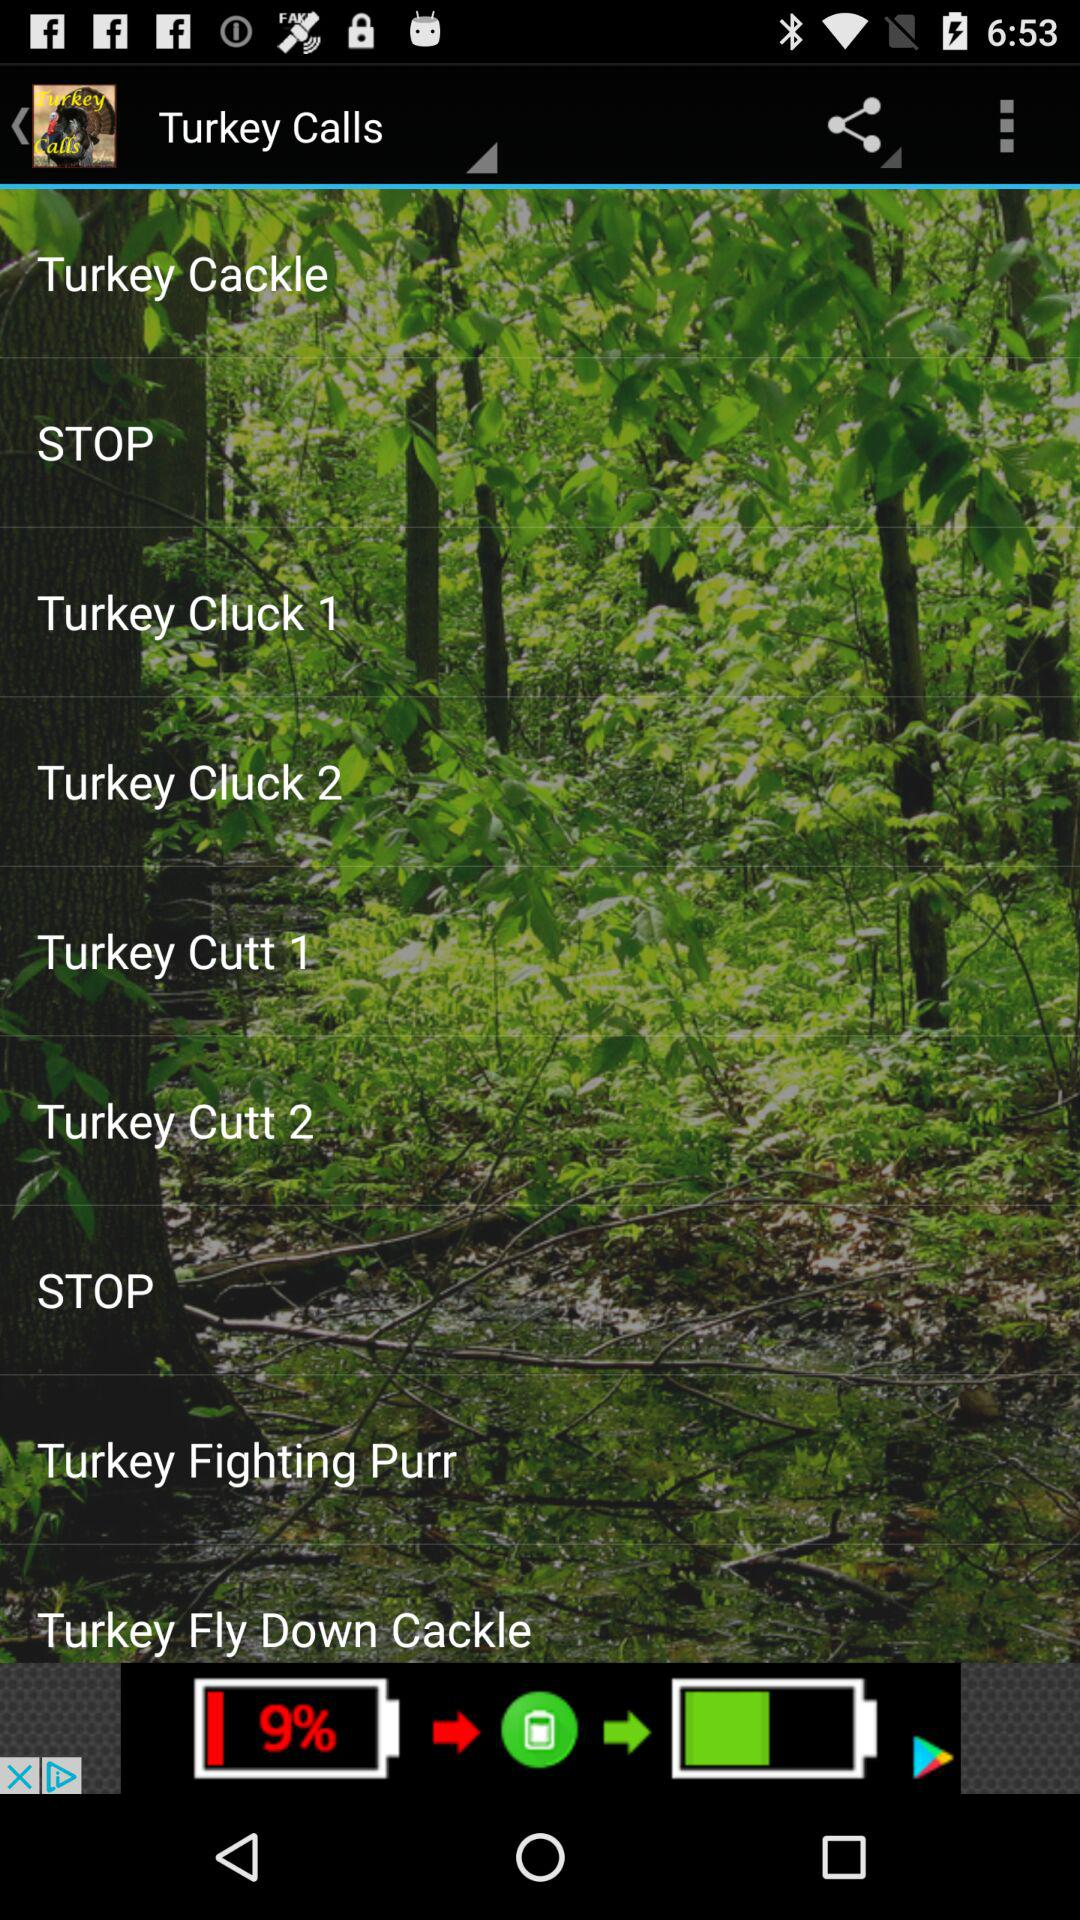What is the name of the application? The name of the application is "Turkey Calls". 